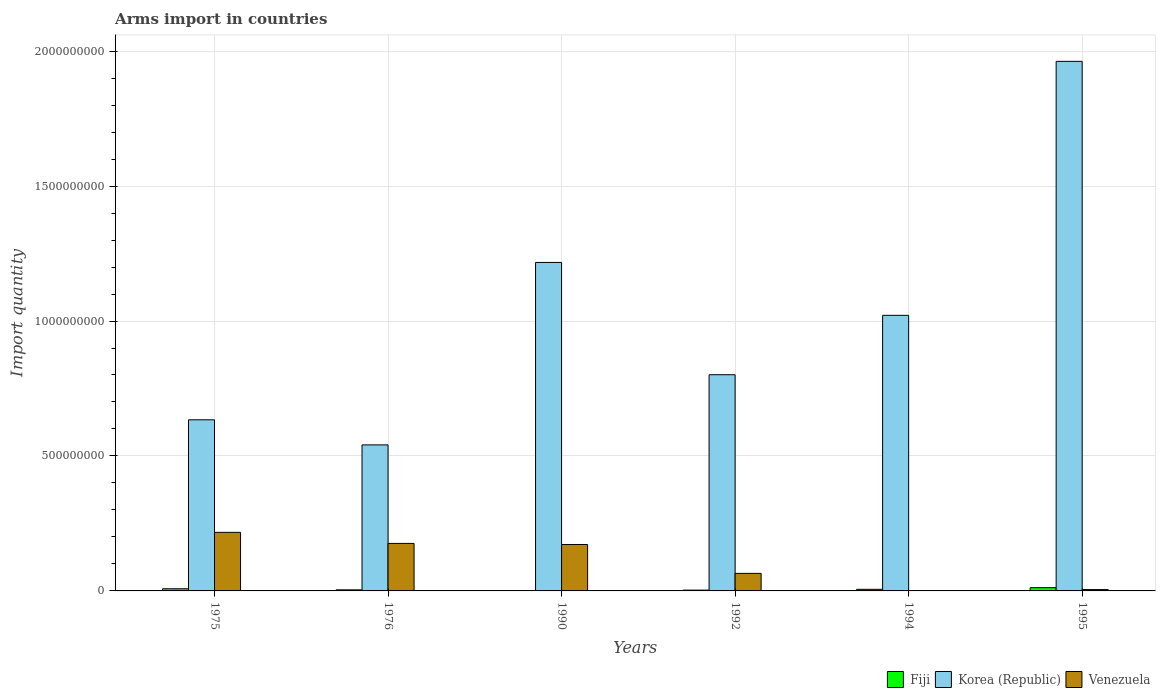How many groups of bars are there?
Your answer should be compact. 6. How many bars are there on the 1st tick from the right?
Your answer should be very brief. 3. What is the label of the 5th group of bars from the left?
Provide a succinct answer. 1994. In how many cases, is the number of bars for a given year not equal to the number of legend labels?
Keep it short and to the point. 0. What is the total arms import in Korea (Republic) in 1975?
Your answer should be very brief. 6.34e+08. Across all years, what is the maximum total arms import in Korea (Republic)?
Ensure brevity in your answer.  1.96e+09. In which year was the total arms import in Fiji minimum?
Offer a very short reply. 1990. What is the total total arms import in Fiji in the graph?
Your response must be concise. 3.40e+07. What is the difference between the total arms import in Korea (Republic) in 1990 and that in 1994?
Your answer should be very brief. 1.96e+08. What is the difference between the total arms import in Venezuela in 1992 and the total arms import in Korea (Republic) in 1975?
Provide a succinct answer. -5.69e+08. What is the average total arms import in Venezuela per year?
Keep it short and to the point. 1.06e+08. In the year 1995, what is the difference between the total arms import in Korea (Republic) and total arms import in Fiji?
Offer a terse response. 1.95e+09. Is the total arms import in Venezuela in 1975 less than that in 1995?
Offer a very short reply. No. Is the difference between the total arms import in Korea (Republic) in 1975 and 1990 greater than the difference between the total arms import in Fiji in 1975 and 1990?
Your response must be concise. No. What is the difference between the highest and the lowest total arms import in Korea (Republic)?
Provide a succinct answer. 1.42e+09. What does the 2nd bar from the left in 1994 represents?
Provide a short and direct response. Korea (Republic). What does the 3rd bar from the right in 1976 represents?
Give a very brief answer. Fiji. Is it the case that in every year, the sum of the total arms import in Fiji and total arms import in Venezuela is greater than the total arms import in Korea (Republic)?
Ensure brevity in your answer.  No. Does the graph contain any zero values?
Provide a short and direct response. No. Does the graph contain grids?
Your response must be concise. Yes. Where does the legend appear in the graph?
Your answer should be very brief. Bottom right. How many legend labels are there?
Offer a very short reply. 3. What is the title of the graph?
Your answer should be very brief. Arms import in countries. What is the label or title of the Y-axis?
Ensure brevity in your answer.  Import quantity. What is the Import quantity in Korea (Republic) in 1975?
Keep it short and to the point. 6.34e+08. What is the Import quantity in Venezuela in 1975?
Offer a terse response. 2.17e+08. What is the Import quantity of Korea (Republic) in 1976?
Provide a succinct answer. 5.41e+08. What is the Import quantity of Venezuela in 1976?
Your answer should be compact. 1.76e+08. What is the Import quantity in Fiji in 1990?
Your answer should be very brief. 1.00e+06. What is the Import quantity in Korea (Republic) in 1990?
Offer a very short reply. 1.22e+09. What is the Import quantity in Venezuela in 1990?
Provide a succinct answer. 1.72e+08. What is the Import quantity of Fiji in 1992?
Keep it short and to the point. 3.00e+06. What is the Import quantity of Korea (Republic) in 1992?
Make the answer very short. 8.01e+08. What is the Import quantity in Venezuela in 1992?
Provide a succinct answer. 6.50e+07. What is the Import quantity in Korea (Republic) in 1994?
Keep it short and to the point. 1.02e+09. What is the Import quantity of Fiji in 1995?
Your answer should be very brief. 1.20e+07. What is the Import quantity in Korea (Republic) in 1995?
Provide a short and direct response. 1.96e+09. Across all years, what is the maximum Import quantity in Fiji?
Your answer should be very brief. 1.20e+07. Across all years, what is the maximum Import quantity of Korea (Republic)?
Make the answer very short. 1.96e+09. Across all years, what is the maximum Import quantity in Venezuela?
Give a very brief answer. 2.17e+08. Across all years, what is the minimum Import quantity in Fiji?
Offer a terse response. 1.00e+06. Across all years, what is the minimum Import quantity of Korea (Republic)?
Your response must be concise. 5.41e+08. What is the total Import quantity in Fiji in the graph?
Keep it short and to the point. 3.40e+07. What is the total Import quantity in Korea (Republic) in the graph?
Keep it short and to the point. 6.18e+09. What is the total Import quantity in Venezuela in the graph?
Keep it short and to the point. 6.36e+08. What is the difference between the Import quantity of Fiji in 1975 and that in 1976?
Make the answer very short. 4.00e+06. What is the difference between the Import quantity in Korea (Republic) in 1975 and that in 1976?
Provide a succinct answer. 9.30e+07. What is the difference between the Import quantity of Venezuela in 1975 and that in 1976?
Provide a succinct answer. 4.10e+07. What is the difference between the Import quantity of Fiji in 1975 and that in 1990?
Keep it short and to the point. 7.00e+06. What is the difference between the Import quantity of Korea (Republic) in 1975 and that in 1990?
Your answer should be very brief. -5.83e+08. What is the difference between the Import quantity of Venezuela in 1975 and that in 1990?
Offer a terse response. 4.50e+07. What is the difference between the Import quantity in Korea (Republic) in 1975 and that in 1992?
Your response must be concise. -1.67e+08. What is the difference between the Import quantity of Venezuela in 1975 and that in 1992?
Your response must be concise. 1.52e+08. What is the difference between the Import quantity of Fiji in 1975 and that in 1994?
Keep it short and to the point. 2.00e+06. What is the difference between the Import quantity in Korea (Republic) in 1975 and that in 1994?
Make the answer very short. -3.87e+08. What is the difference between the Import quantity in Venezuela in 1975 and that in 1994?
Your answer should be very brief. 2.16e+08. What is the difference between the Import quantity in Fiji in 1975 and that in 1995?
Provide a succinct answer. -4.00e+06. What is the difference between the Import quantity in Korea (Republic) in 1975 and that in 1995?
Make the answer very short. -1.33e+09. What is the difference between the Import quantity in Venezuela in 1975 and that in 1995?
Provide a short and direct response. 2.12e+08. What is the difference between the Import quantity in Fiji in 1976 and that in 1990?
Your answer should be compact. 3.00e+06. What is the difference between the Import quantity in Korea (Republic) in 1976 and that in 1990?
Your response must be concise. -6.76e+08. What is the difference between the Import quantity of Venezuela in 1976 and that in 1990?
Make the answer very short. 4.00e+06. What is the difference between the Import quantity in Fiji in 1976 and that in 1992?
Your answer should be compact. 1.00e+06. What is the difference between the Import quantity in Korea (Republic) in 1976 and that in 1992?
Give a very brief answer. -2.60e+08. What is the difference between the Import quantity of Venezuela in 1976 and that in 1992?
Make the answer very short. 1.11e+08. What is the difference between the Import quantity of Korea (Republic) in 1976 and that in 1994?
Ensure brevity in your answer.  -4.80e+08. What is the difference between the Import quantity in Venezuela in 1976 and that in 1994?
Make the answer very short. 1.75e+08. What is the difference between the Import quantity of Fiji in 1976 and that in 1995?
Your answer should be very brief. -8.00e+06. What is the difference between the Import quantity of Korea (Republic) in 1976 and that in 1995?
Ensure brevity in your answer.  -1.42e+09. What is the difference between the Import quantity in Venezuela in 1976 and that in 1995?
Make the answer very short. 1.71e+08. What is the difference between the Import quantity in Fiji in 1990 and that in 1992?
Give a very brief answer. -2.00e+06. What is the difference between the Import quantity of Korea (Republic) in 1990 and that in 1992?
Offer a terse response. 4.16e+08. What is the difference between the Import quantity in Venezuela in 1990 and that in 1992?
Provide a short and direct response. 1.07e+08. What is the difference between the Import quantity of Fiji in 1990 and that in 1994?
Your answer should be compact. -5.00e+06. What is the difference between the Import quantity of Korea (Republic) in 1990 and that in 1994?
Provide a succinct answer. 1.96e+08. What is the difference between the Import quantity of Venezuela in 1990 and that in 1994?
Ensure brevity in your answer.  1.71e+08. What is the difference between the Import quantity in Fiji in 1990 and that in 1995?
Offer a very short reply. -1.10e+07. What is the difference between the Import quantity of Korea (Republic) in 1990 and that in 1995?
Offer a very short reply. -7.45e+08. What is the difference between the Import quantity in Venezuela in 1990 and that in 1995?
Provide a succinct answer. 1.67e+08. What is the difference between the Import quantity in Korea (Republic) in 1992 and that in 1994?
Keep it short and to the point. -2.20e+08. What is the difference between the Import quantity of Venezuela in 1992 and that in 1994?
Provide a short and direct response. 6.40e+07. What is the difference between the Import quantity of Fiji in 1992 and that in 1995?
Offer a terse response. -9.00e+06. What is the difference between the Import quantity in Korea (Republic) in 1992 and that in 1995?
Offer a terse response. -1.16e+09. What is the difference between the Import quantity in Venezuela in 1992 and that in 1995?
Your response must be concise. 6.00e+07. What is the difference between the Import quantity of Fiji in 1994 and that in 1995?
Offer a terse response. -6.00e+06. What is the difference between the Import quantity of Korea (Republic) in 1994 and that in 1995?
Keep it short and to the point. -9.41e+08. What is the difference between the Import quantity in Venezuela in 1994 and that in 1995?
Offer a very short reply. -4.00e+06. What is the difference between the Import quantity in Fiji in 1975 and the Import quantity in Korea (Republic) in 1976?
Ensure brevity in your answer.  -5.33e+08. What is the difference between the Import quantity in Fiji in 1975 and the Import quantity in Venezuela in 1976?
Your response must be concise. -1.68e+08. What is the difference between the Import quantity in Korea (Republic) in 1975 and the Import quantity in Venezuela in 1976?
Ensure brevity in your answer.  4.58e+08. What is the difference between the Import quantity in Fiji in 1975 and the Import quantity in Korea (Republic) in 1990?
Your answer should be very brief. -1.21e+09. What is the difference between the Import quantity in Fiji in 1975 and the Import quantity in Venezuela in 1990?
Offer a very short reply. -1.64e+08. What is the difference between the Import quantity of Korea (Republic) in 1975 and the Import quantity of Venezuela in 1990?
Your response must be concise. 4.62e+08. What is the difference between the Import quantity of Fiji in 1975 and the Import quantity of Korea (Republic) in 1992?
Your response must be concise. -7.93e+08. What is the difference between the Import quantity in Fiji in 1975 and the Import quantity in Venezuela in 1992?
Your answer should be compact. -5.70e+07. What is the difference between the Import quantity of Korea (Republic) in 1975 and the Import quantity of Venezuela in 1992?
Offer a terse response. 5.69e+08. What is the difference between the Import quantity of Fiji in 1975 and the Import quantity of Korea (Republic) in 1994?
Provide a succinct answer. -1.01e+09. What is the difference between the Import quantity of Korea (Republic) in 1975 and the Import quantity of Venezuela in 1994?
Ensure brevity in your answer.  6.33e+08. What is the difference between the Import quantity in Fiji in 1975 and the Import quantity in Korea (Republic) in 1995?
Your answer should be very brief. -1.95e+09. What is the difference between the Import quantity in Korea (Republic) in 1975 and the Import quantity in Venezuela in 1995?
Provide a succinct answer. 6.29e+08. What is the difference between the Import quantity of Fiji in 1976 and the Import quantity of Korea (Republic) in 1990?
Keep it short and to the point. -1.21e+09. What is the difference between the Import quantity of Fiji in 1976 and the Import quantity of Venezuela in 1990?
Offer a terse response. -1.68e+08. What is the difference between the Import quantity of Korea (Republic) in 1976 and the Import quantity of Venezuela in 1990?
Ensure brevity in your answer.  3.69e+08. What is the difference between the Import quantity in Fiji in 1976 and the Import quantity in Korea (Republic) in 1992?
Ensure brevity in your answer.  -7.97e+08. What is the difference between the Import quantity of Fiji in 1976 and the Import quantity of Venezuela in 1992?
Your answer should be compact. -6.10e+07. What is the difference between the Import quantity of Korea (Republic) in 1976 and the Import quantity of Venezuela in 1992?
Keep it short and to the point. 4.76e+08. What is the difference between the Import quantity in Fiji in 1976 and the Import quantity in Korea (Republic) in 1994?
Give a very brief answer. -1.02e+09. What is the difference between the Import quantity in Fiji in 1976 and the Import quantity in Venezuela in 1994?
Make the answer very short. 3.00e+06. What is the difference between the Import quantity of Korea (Republic) in 1976 and the Import quantity of Venezuela in 1994?
Offer a terse response. 5.40e+08. What is the difference between the Import quantity of Fiji in 1976 and the Import quantity of Korea (Republic) in 1995?
Offer a terse response. -1.96e+09. What is the difference between the Import quantity of Korea (Republic) in 1976 and the Import quantity of Venezuela in 1995?
Ensure brevity in your answer.  5.36e+08. What is the difference between the Import quantity in Fiji in 1990 and the Import quantity in Korea (Republic) in 1992?
Provide a short and direct response. -8.00e+08. What is the difference between the Import quantity in Fiji in 1990 and the Import quantity in Venezuela in 1992?
Ensure brevity in your answer.  -6.40e+07. What is the difference between the Import quantity in Korea (Republic) in 1990 and the Import quantity in Venezuela in 1992?
Offer a terse response. 1.15e+09. What is the difference between the Import quantity in Fiji in 1990 and the Import quantity in Korea (Republic) in 1994?
Offer a terse response. -1.02e+09. What is the difference between the Import quantity of Korea (Republic) in 1990 and the Import quantity of Venezuela in 1994?
Your answer should be very brief. 1.22e+09. What is the difference between the Import quantity in Fiji in 1990 and the Import quantity in Korea (Republic) in 1995?
Offer a terse response. -1.96e+09. What is the difference between the Import quantity in Korea (Republic) in 1990 and the Import quantity in Venezuela in 1995?
Your response must be concise. 1.21e+09. What is the difference between the Import quantity of Fiji in 1992 and the Import quantity of Korea (Republic) in 1994?
Make the answer very short. -1.02e+09. What is the difference between the Import quantity of Fiji in 1992 and the Import quantity of Venezuela in 1994?
Your response must be concise. 2.00e+06. What is the difference between the Import quantity of Korea (Republic) in 1992 and the Import quantity of Venezuela in 1994?
Offer a terse response. 8.00e+08. What is the difference between the Import quantity of Fiji in 1992 and the Import quantity of Korea (Republic) in 1995?
Provide a succinct answer. -1.96e+09. What is the difference between the Import quantity in Korea (Republic) in 1992 and the Import quantity in Venezuela in 1995?
Make the answer very short. 7.96e+08. What is the difference between the Import quantity of Fiji in 1994 and the Import quantity of Korea (Republic) in 1995?
Provide a short and direct response. -1.96e+09. What is the difference between the Import quantity in Korea (Republic) in 1994 and the Import quantity in Venezuela in 1995?
Provide a succinct answer. 1.02e+09. What is the average Import quantity in Fiji per year?
Provide a succinct answer. 5.67e+06. What is the average Import quantity in Korea (Republic) per year?
Give a very brief answer. 1.03e+09. What is the average Import quantity in Venezuela per year?
Your response must be concise. 1.06e+08. In the year 1975, what is the difference between the Import quantity in Fiji and Import quantity in Korea (Republic)?
Ensure brevity in your answer.  -6.26e+08. In the year 1975, what is the difference between the Import quantity of Fiji and Import quantity of Venezuela?
Your answer should be compact. -2.09e+08. In the year 1975, what is the difference between the Import quantity of Korea (Republic) and Import quantity of Venezuela?
Your answer should be very brief. 4.17e+08. In the year 1976, what is the difference between the Import quantity in Fiji and Import quantity in Korea (Republic)?
Make the answer very short. -5.37e+08. In the year 1976, what is the difference between the Import quantity of Fiji and Import quantity of Venezuela?
Offer a very short reply. -1.72e+08. In the year 1976, what is the difference between the Import quantity of Korea (Republic) and Import quantity of Venezuela?
Provide a succinct answer. 3.65e+08. In the year 1990, what is the difference between the Import quantity of Fiji and Import quantity of Korea (Republic)?
Keep it short and to the point. -1.22e+09. In the year 1990, what is the difference between the Import quantity in Fiji and Import quantity in Venezuela?
Offer a terse response. -1.71e+08. In the year 1990, what is the difference between the Import quantity in Korea (Republic) and Import quantity in Venezuela?
Offer a very short reply. 1.04e+09. In the year 1992, what is the difference between the Import quantity of Fiji and Import quantity of Korea (Republic)?
Keep it short and to the point. -7.98e+08. In the year 1992, what is the difference between the Import quantity of Fiji and Import quantity of Venezuela?
Your answer should be compact. -6.20e+07. In the year 1992, what is the difference between the Import quantity in Korea (Republic) and Import quantity in Venezuela?
Your answer should be very brief. 7.36e+08. In the year 1994, what is the difference between the Import quantity of Fiji and Import quantity of Korea (Republic)?
Your response must be concise. -1.02e+09. In the year 1994, what is the difference between the Import quantity of Korea (Republic) and Import quantity of Venezuela?
Offer a terse response. 1.02e+09. In the year 1995, what is the difference between the Import quantity in Fiji and Import quantity in Korea (Republic)?
Keep it short and to the point. -1.95e+09. In the year 1995, what is the difference between the Import quantity of Korea (Republic) and Import quantity of Venezuela?
Your answer should be very brief. 1.96e+09. What is the ratio of the Import quantity in Fiji in 1975 to that in 1976?
Your answer should be very brief. 2. What is the ratio of the Import quantity in Korea (Republic) in 1975 to that in 1976?
Your answer should be compact. 1.17. What is the ratio of the Import quantity of Venezuela in 1975 to that in 1976?
Offer a terse response. 1.23. What is the ratio of the Import quantity in Fiji in 1975 to that in 1990?
Your answer should be very brief. 8. What is the ratio of the Import quantity in Korea (Republic) in 1975 to that in 1990?
Your answer should be very brief. 0.52. What is the ratio of the Import quantity of Venezuela in 1975 to that in 1990?
Your answer should be very brief. 1.26. What is the ratio of the Import quantity of Fiji in 1975 to that in 1992?
Your response must be concise. 2.67. What is the ratio of the Import quantity in Korea (Republic) in 1975 to that in 1992?
Keep it short and to the point. 0.79. What is the ratio of the Import quantity in Venezuela in 1975 to that in 1992?
Keep it short and to the point. 3.34. What is the ratio of the Import quantity of Fiji in 1975 to that in 1994?
Provide a succinct answer. 1.33. What is the ratio of the Import quantity in Korea (Republic) in 1975 to that in 1994?
Your response must be concise. 0.62. What is the ratio of the Import quantity of Venezuela in 1975 to that in 1994?
Keep it short and to the point. 217. What is the ratio of the Import quantity of Fiji in 1975 to that in 1995?
Your answer should be compact. 0.67. What is the ratio of the Import quantity of Korea (Republic) in 1975 to that in 1995?
Your answer should be compact. 0.32. What is the ratio of the Import quantity of Venezuela in 1975 to that in 1995?
Keep it short and to the point. 43.4. What is the ratio of the Import quantity of Fiji in 1976 to that in 1990?
Your response must be concise. 4. What is the ratio of the Import quantity in Korea (Republic) in 1976 to that in 1990?
Give a very brief answer. 0.44. What is the ratio of the Import quantity in Venezuela in 1976 to that in 1990?
Your response must be concise. 1.02. What is the ratio of the Import quantity of Fiji in 1976 to that in 1992?
Provide a short and direct response. 1.33. What is the ratio of the Import quantity of Korea (Republic) in 1976 to that in 1992?
Your answer should be compact. 0.68. What is the ratio of the Import quantity of Venezuela in 1976 to that in 1992?
Your response must be concise. 2.71. What is the ratio of the Import quantity of Korea (Republic) in 1976 to that in 1994?
Your answer should be compact. 0.53. What is the ratio of the Import quantity in Venezuela in 1976 to that in 1994?
Offer a terse response. 176. What is the ratio of the Import quantity in Fiji in 1976 to that in 1995?
Give a very brief answer. 0.33. What is the ratio of the Import quantity of Korea (Republic) in 1976 to that in 1995?
Your response must be concise. 0.28. What is the ratio of the Import quantity in Venezuela in 1976 to that in 1995?
Offer a terse response. 35.2. What is the ratio of the Import quantity in Korea (Republic) in 1990 to that in 1992?
Give a very brief answer. 1.52. What is the ratio of the Import quantity of Venezuela in 1990 to that in 1992?
Your response must be concise. 2.65. What is the ratio of the Import quantity of Korea (Republic) in 1990 to that in 1994?
Offer a terse response. 1.19. What is the ratio of the Import quantity in Venezuela in 1990 to that in 1994?
Offer a terse response. 172. What is the ratio of the Import quantity of Fiji in 1990 to that in 1995?
Provide a succinct answer. 0.08. What is the ratio of the Import quantity in Korea (Republic) in 1990 to that in 1995?
Provide a succinct answer. 0.62. What is the ratio of the Import quantity of Venezuela in 1990 to that in 1995?
Give a very brief answer. 34.4. What is the ratio of the Import quantity of Fiji in 1992 to that in 1994?
Give a very brief answer. 0.5. What is the ratio of the Import quantity of Korea (Republic) in 1992 to that in 1994?
Your answer should be compact. 0.78. What is the ratio of the Import quantity of Venezuela in 1992 to that in 1994?
Your answer should be very brief. 65. What is the ratio of the Import quantity of Fiji in 1992 to that in 1995?
Your answer should be compact. 0.25. What is the ratio of the Import quantity in Korea (Republic) in 1992 to that in 1995?
Provide a succinct answer. 0.41. What is the ratio of the Import quantity in Korea (Republic) in 1994 to that in 1995?
Give a very brief answer. 0.52. What is the ratio of the Import quantity in Venezuela in 1994 to that in 1995?
Provide a succinct answer. 0.2. What is the difference between the highest and the second highest Import quantity of Korea (Republic)?
Your answer should be compact. 7.45e+08. What is the difference between the highest and the second highest Import quantity of Venezuela?
Your answer should be very brief. 4.10e+07. What is the difference between the highest and the lowest Import quantity in Fiji?
Offer a terse response. 1.10e+07. What is the difference between the highest and the lowest Import quantity in Korea (Republic)?
Your answer should be compact. 1.42e+09. What is the difference between the highest and the lowest Import quantity of Venezuela?
Your response must be concise. 2.16e+08. 